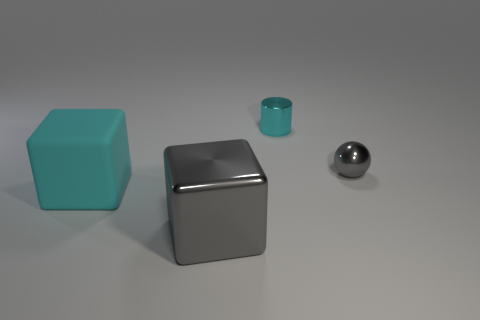Add 1 big cyan shiny blocks. How many objects exist? 5 Subtract all spheres. How many objects are left? 3 Add 3 small cyan metallic cubes. How many small cyan metallic cubes exist? 3 Subtract 1 cyan cubes. How many objects are left? 3 Subtract all cyan cylinders. Subtract all green rubber cubes. How many objects are left? 3 Add 4 gray things. How many gray things are left? 6 